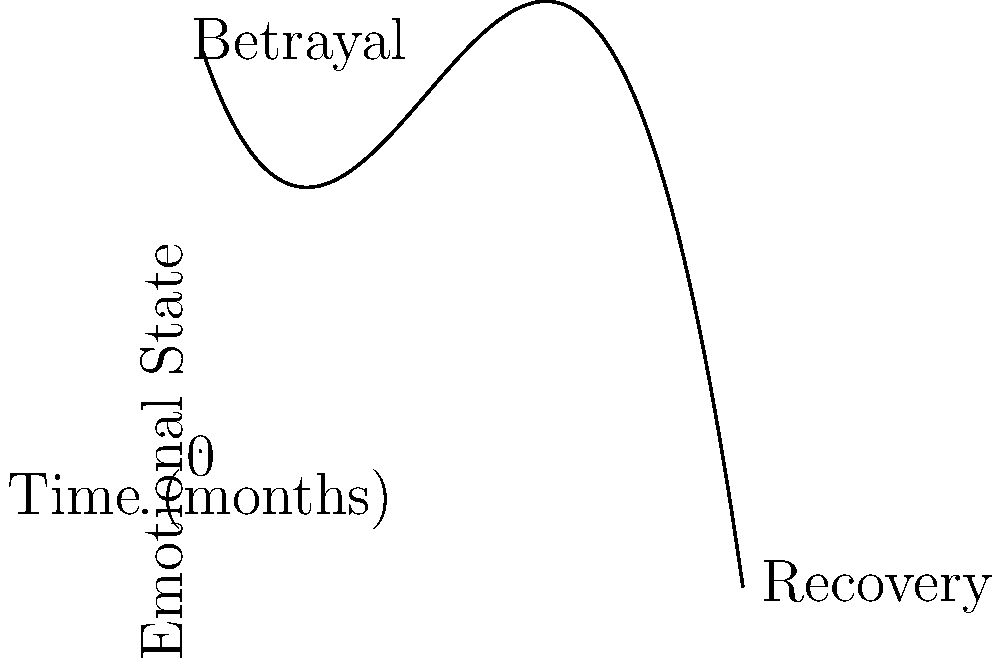The graph above represents the emotional journey of an actor following a betrayal by their talent agent. Analyze the curve and determine at which point (in months) the actor's emotional state was at its lowest. To find the lowest point of the actor's emotional state, we need to analyze the curve:

1. The curve starts high, representing the initial shock and anger of the betrayal.
2. It then descends rapidly, showing the deterioration of the actor's emotional state.
3. The curve reaches its lowest point, which represents the actor's emotional rock bottom.
4. After this low point, the curve begins to ascend, indicating the start of emotional recovery.

To find the exact point of the lowest emotional state, we need to identify where the curve changes from descending to ascending. This occurs at the minimum point of the curve.

Visually, we can estimate this point to be around 2 months after the betrayal.

The mathematical way to find this would be to calculate the derivative of the function and set it to zero, but for this visual analysis, an estimation based on the graph is sufficient.
Answer: 2 months 